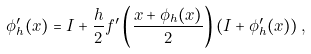Convert formula to latex. <formula><loc_0><loc_0><loc_500><loc_500>\phi _ { h } ^ { \prime } ( x ) = I + \frac { h } { 2 } f ^ { \prime } \left ( \frac { x + \phi _ { h } ( x ) } { 2 } \right ) \left ( I + \phi _ { h } ^ { \prime } ( x ) \right ) ,</formula> 